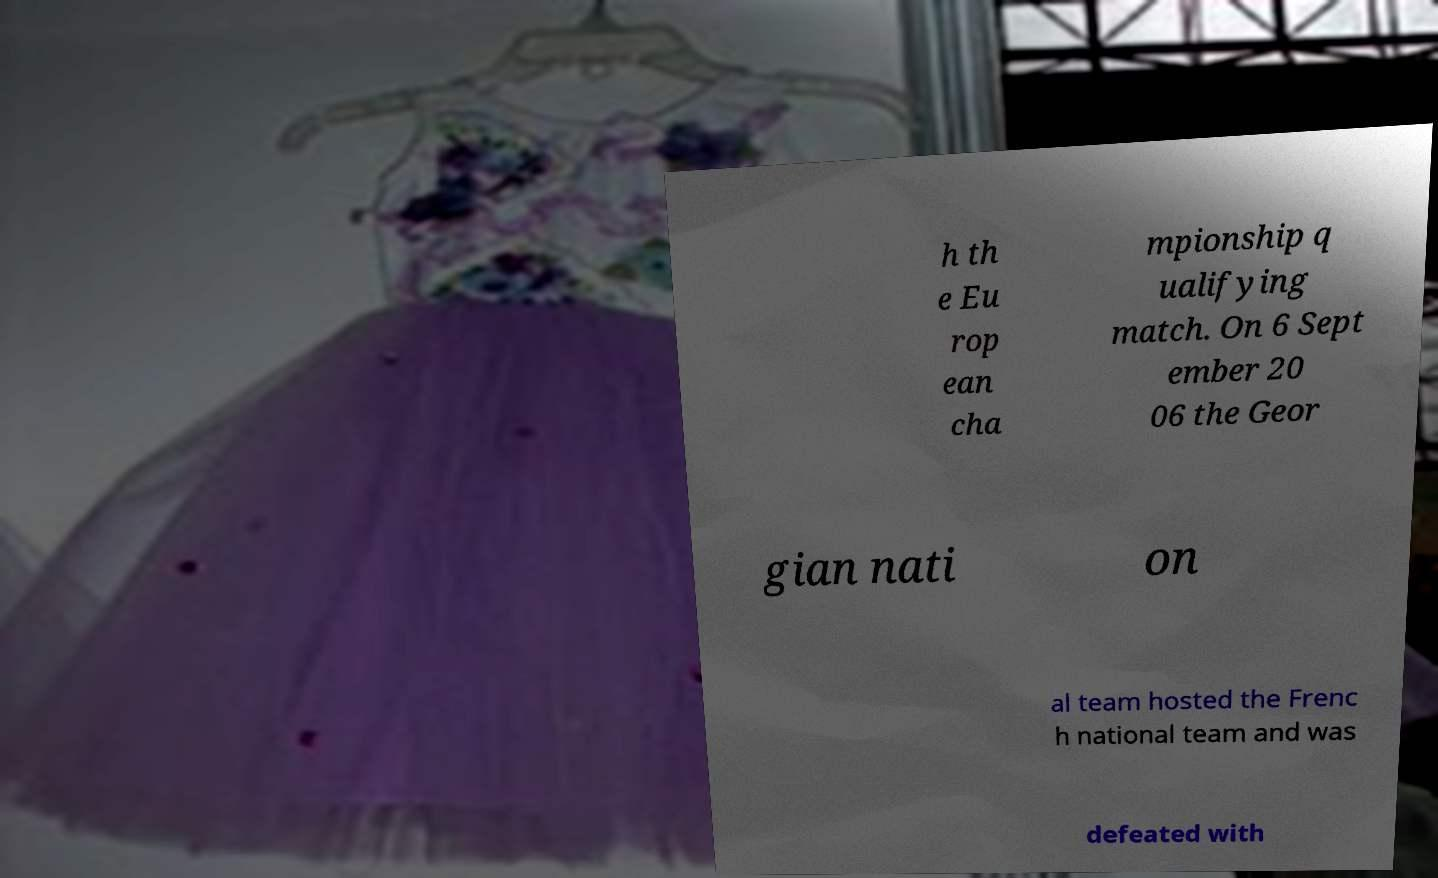Please identify and transcribe the text found in this image. h th e Eu rop ean cha mpionship q ualifying match. On 6 Sept ember 20 06 the Geor gian nati on al team hosted the Frenc h national team and was defeated with 